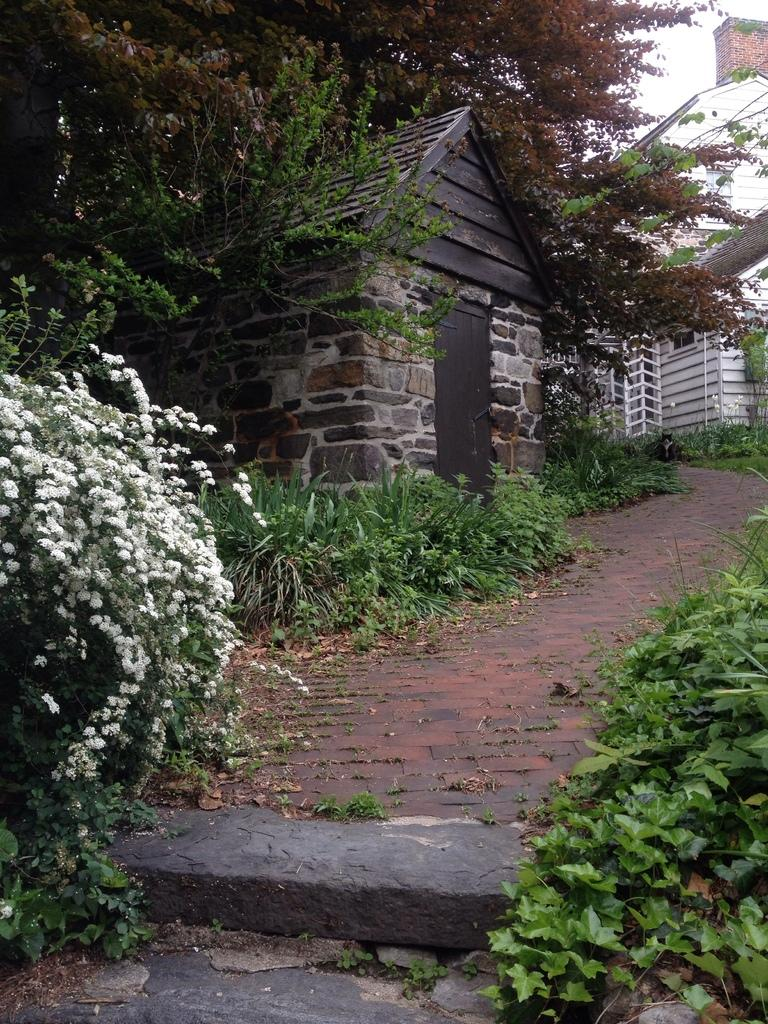What types of vegetation can be seen in the image? There are flowers and plants in the image. What type of outdoor space is visible in the image? There is a patio in the image. What architectural feature can be seen in the image? There is a door in the image. What other natural elements are present in the image? There are trees in the image. What type of structures can be seen in the image? There are buildings in the image. What is visible in the background of the image? The sky is visible in the background of the image. Can you see a kite flying in the sky in the image? There is no kite visible in the sky in the image. What type of sea creature can be seen swimming in the image? There is no sea or sea creature present in the image. 